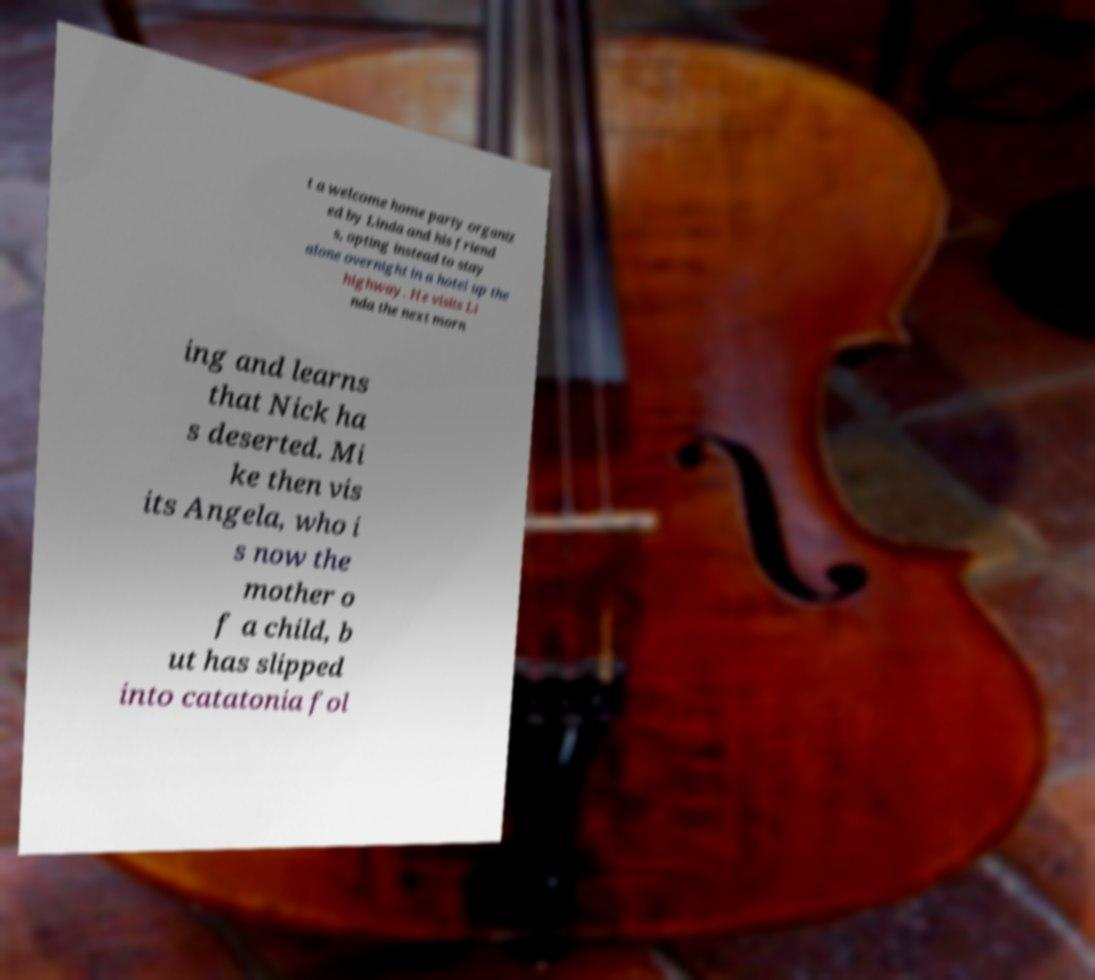Can you accurately transcribe the text from the provided image for me? t a welcome home party organiz ed by Linda and his friend s, opting instead to stay alone overnight in a hotel up the highway. He visits Li nda the next morn ing and learns that Nick ha s deserted. Mi ke then vis its Angela, who i s now the mother o f a child, b ut has slipped into catatonia fol 